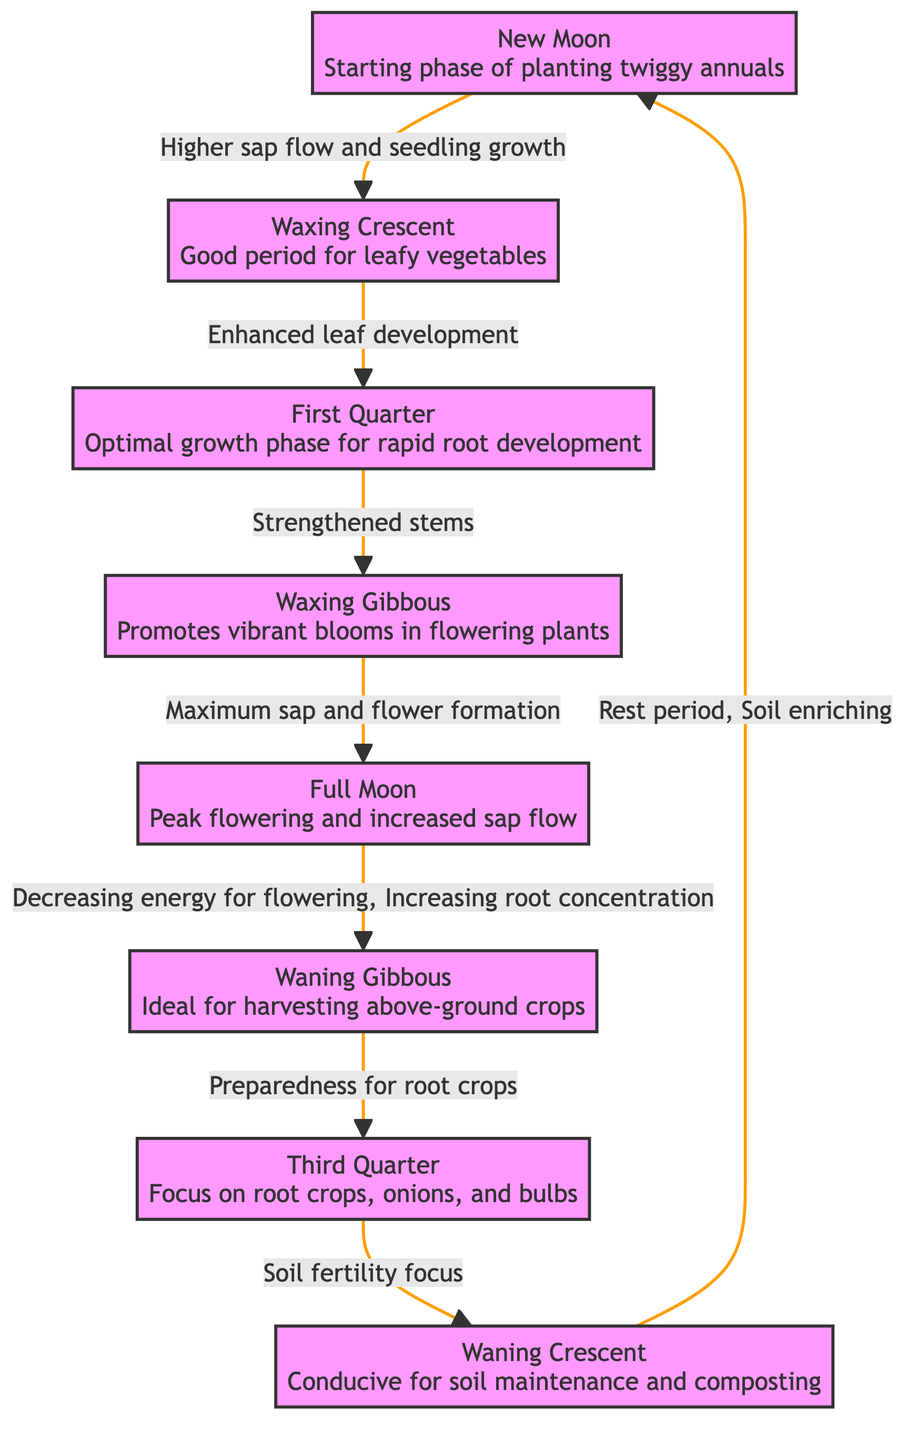What is the starting phase for planting twiggy annuals? The diagram shows that the starting phase for planting twiggy annuals is the "New Moon." This phase is specifically labeled and connected to the next phase by an arrow, indicating its position in the growth cycle.
Answer: New Moon Which phase promotes vibrant blooms in flowering plants? According to the diagram, the phase that promotes vibrant blooms in flowering plants is the "Waxing Gibbous." It is linked to the previous phase and emphasizes its effect on flowering plants.
Answer: Waxing Gibbous How many phases are depicted in the diagram? The diagram clearly lists eight distinct phases of moon influence on plant growth. Each phase is represented by a labeled node and contributes to the overall cycle of plant development.
Answer: 8 What is the relationship between the Full Moon and the Waning Gibbous? The Full Moon is connected to the Waning Gibbous phase, and the diagram indicates that during the Full Moon, there is peak flowering and increased sap flow. The subsequent phase focuses on decreasing energy for flowering while increasing root concentration, which reflects a transition in plant priorities.
Answer: Decreasing energy for flowering, Increasing root concentration What focus is emphasized during the Third Quarter phase? The diagram indicates that the focus during the Third Quarter phase is on root crops, onions, and bulbs. This is explicitly mentioned in the node representing the Third Quarter phase, indicating its role in this part of the growth cycle.
Answer: Root crops, onions, and bulbs Which phase is described as conducive for soil maintenance and composting? The diagram specifically states that the "Waning Crescent" phase is conducive for soil maintenance and composting. This description is directly associated with that particular phase, making it clear where soil health is prioritized.
Answer: Waning Crescent What is the role of sap flow during the New Moon phase? The New Moon phase is associated with higher sap flow and seedling growth, indicating that it supports the initial stages of planting. The arrow leads to the next phase, underlining its importance in the growth cycle.
Answer: Higher sap flow and seedling growth What phase follows the Waxing Gibbous? The diagram illustrates that the phase following the Waxing Gibbous is the Full Moon. This connection is arrowed, making it visually clear which phase comes next in the cycle of plant growth.
Answer: Full Moon 